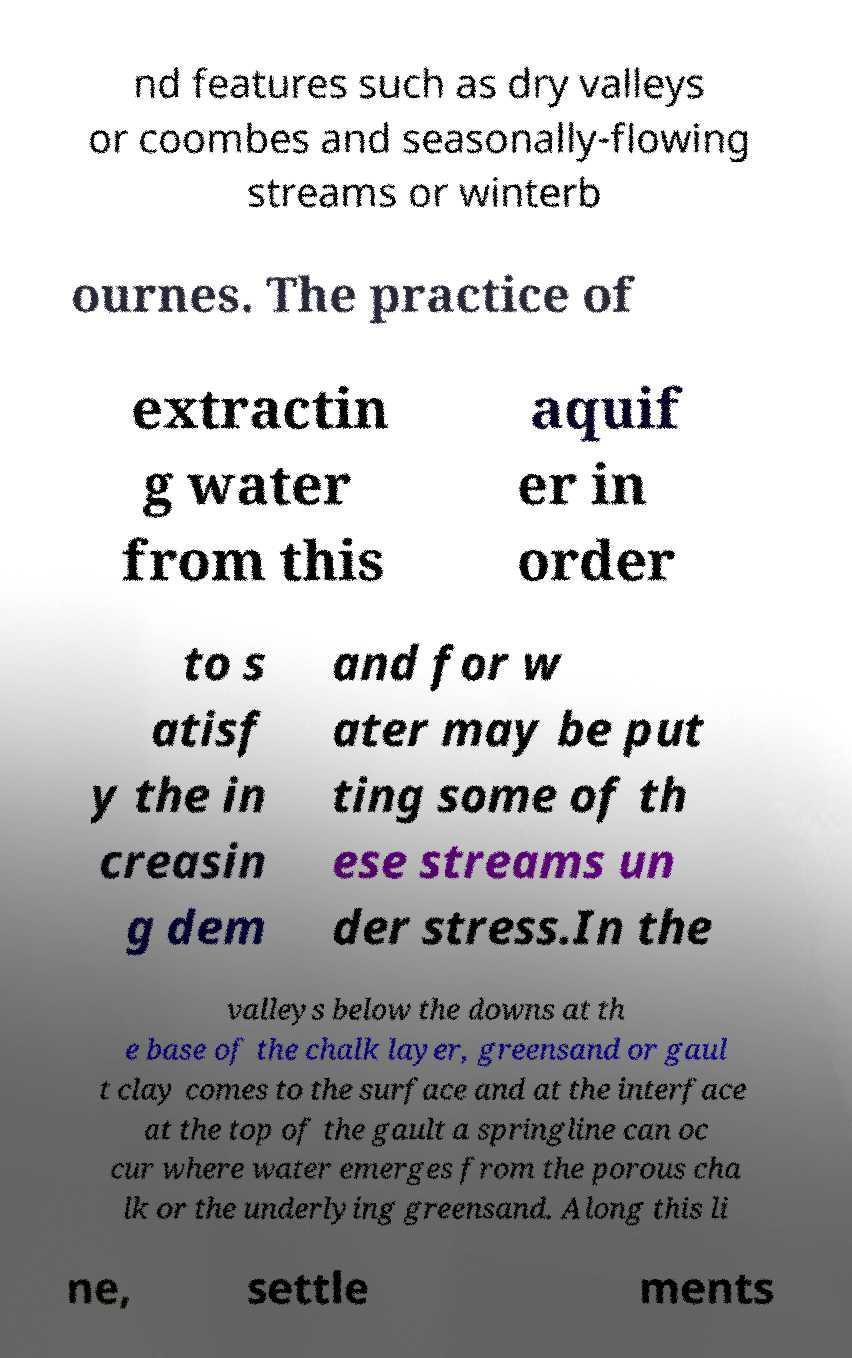Could you extract and type out the text from this image? nd features such as dry valleys or coombes and seasonally-flowing streams or winterb ournes. The practice of extractin g water from this aquif er in order to s atisf y the in creasin g dem and for w ater may be put ting some of th ese streams un der stress.In the valleys below the downs at th e base of the chalk layer, greensand or gaul t clay comes to the surface and at the interface at the top of the gault a springline can oc cur where water emerges from the porous cha lk or the underlying greensand. Along this li ne, settle ments 